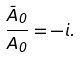<formula> <loc_0><loc_0><loc_500><loc_500>\frac { \bar { A } _ { 0 } } { A _ { 0 } } = - i .</formula> 